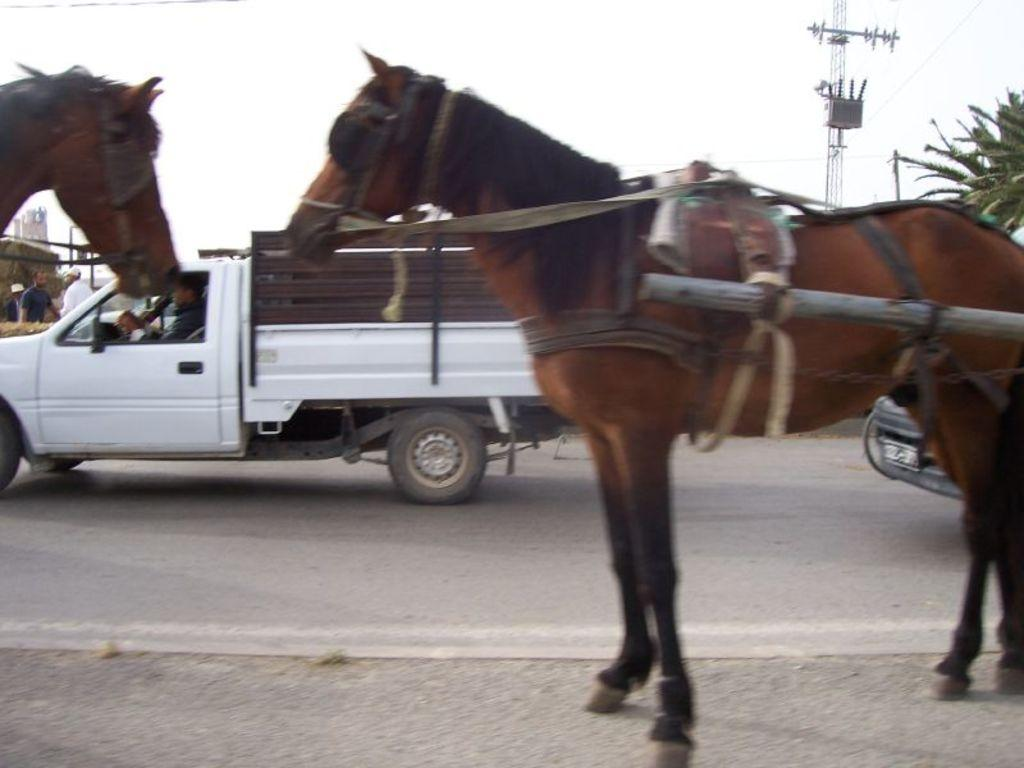What animals are present in the image? There are horses in the image. What type of transportation can be seen on the road in the image? There are vehicles on the road in the image. What structure is located on the right side of the image? There is an electric pole on the right side of the image. What type of quilt is being used to cover the horses in the image? There is no quilt present in the image, and the horses are not covered. 